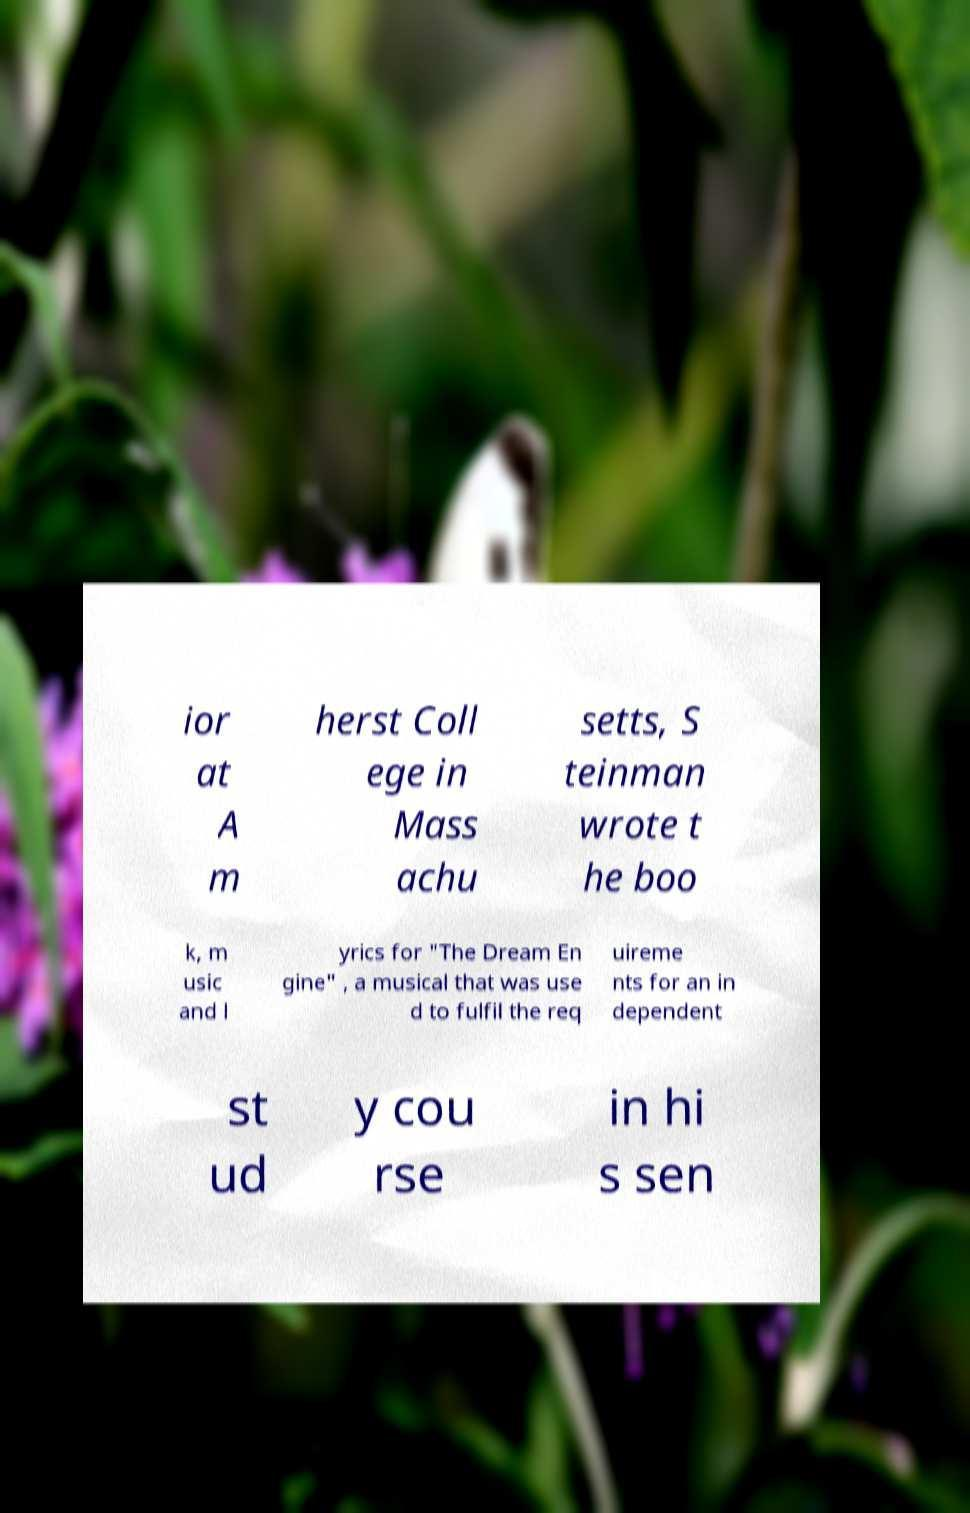There's text embedded in this image that I need extracted. Can you transcribe it verbatim? ior at A m herst Coll ege in Mass achu setts, S teinman wrote t he boo k, m usic and l yrics for "The Dream En gine" , a musical that was use d to fulfil the req uireme nts for an in dependent st ud y cou rse in hi s sen 